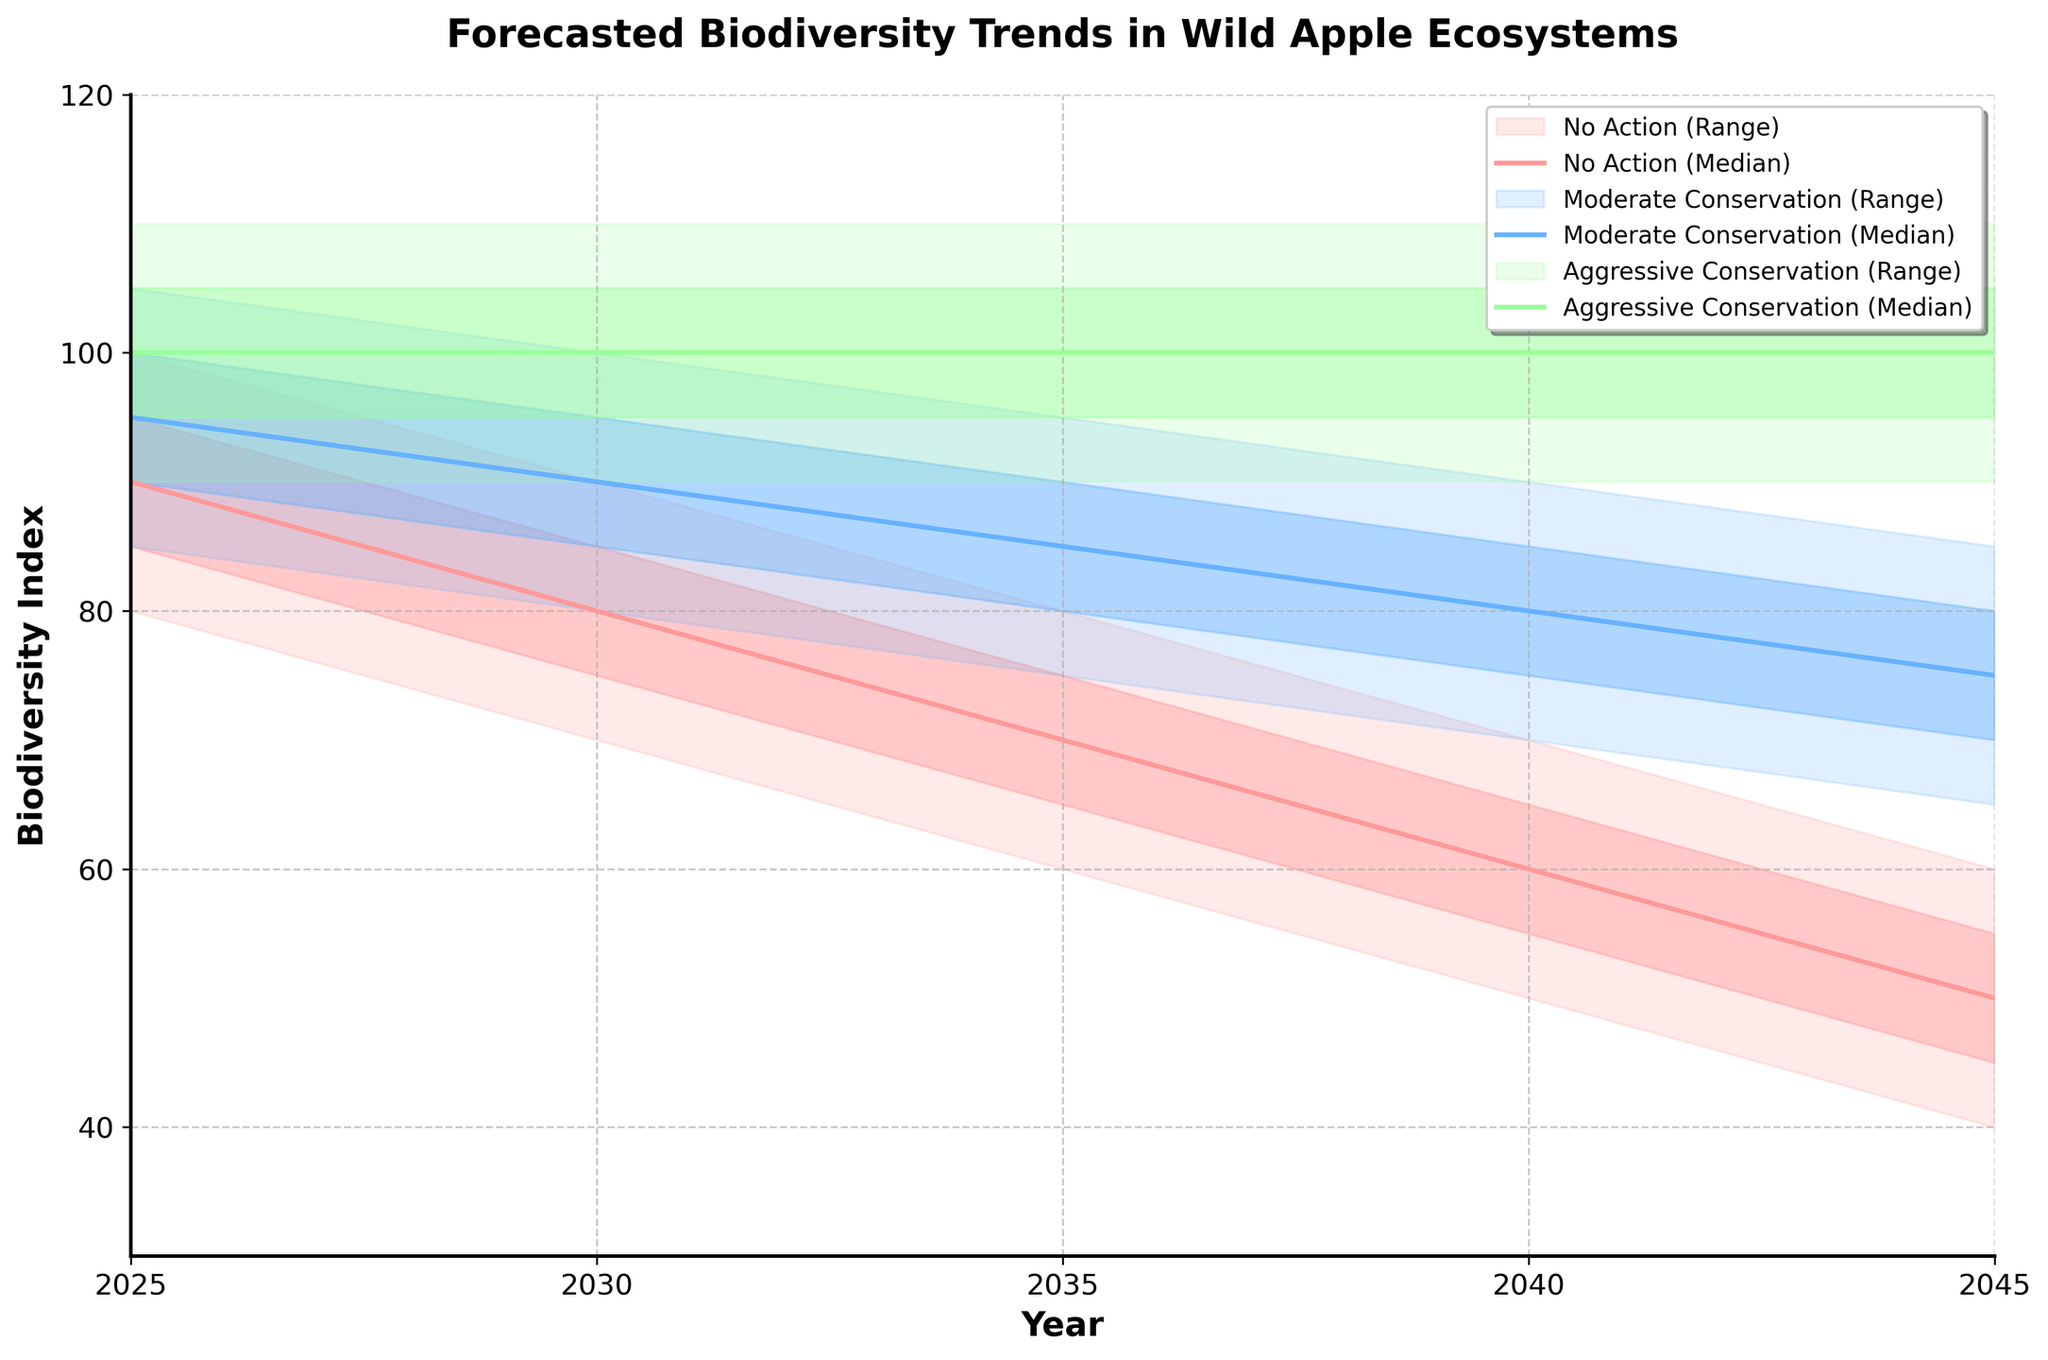How many years are shown in the chart? The x-axis of the chart displays the years. Counting the unique years from the chart, there are six years: 2025, 2030, 2035, 2040, and 2045
Answer: Five What is the title of the chart? The title of the chart is displayed prominently at the top of the figure. It reads "Forecasted Biodiversity Trends in Wild Apple Ecosystems."
Answer: Forecasted Biodiversity Trends in Wild Apple Ecosystems Which conservation scenario has the highest median biodiversity value in 2045? To find the highest median value for 2045, compare the median values for each scenario in that year. The Aggressive Conservation scenario has the highest median value of 100.
Answer: Aggressive Conservation By how much does the median biodiversity index for the "No Action" scenario decrease from 2025 to 2045? Subtract the median value of the "No Action" scenario in 2025 (90) from the median value in 2045 (50). The decrease is 90 - 50 = 40.
Answer: 40 Between 2025 and 2045, which scenario shows the smallest range in biodiversity index? The range is calculated as UpperBound - LowerBound for each scenario. The "Aggressive Conservation" scenario consistently shows a range of 20 across all years.
Answer: Aggressive Conservation What are the lower and upper bounds for the biodiversity index in the "Moderate Conservation" scenario in 2040? From the chart, look at the lower and upper bounds for the Moderate Conservation scenario in 2040. The lower bound is 70, and the upper bound is 90.
Answer: 70 and 90 Which scenario shows the steepest decline in median biodiversity index between 2025 and 2045? By examining the median lines for each scenario from 2025 to 2045, the "No Action" scenario shows a steep decline from 90 in 2025 to 50 in 2045, a total drop of 40 units.
Answer: No Action Compare the median biodiversity index for the "Moderate Conservation" and "Aggressive Conservation" scenarios in 2035. Which one is higher and by how much? The median biodiversity index in 2035 for the "Moderate Conservation" scenario is 85, and for the "Aggressive Conservation" scenario is 100. The difference is 100 - 85 = 15.
Answer: Aggressive Conservation by 15 What is the average lower middle bound of the biodiversity index for the "No Action" scenario across all years? Sum the lower middle bounds for the "No Action" scenario across all years (85+75+65+55+45) and divide by the number of years (5). The average is (85+75+65+55+45)/5 = 65.
Answer: 65 